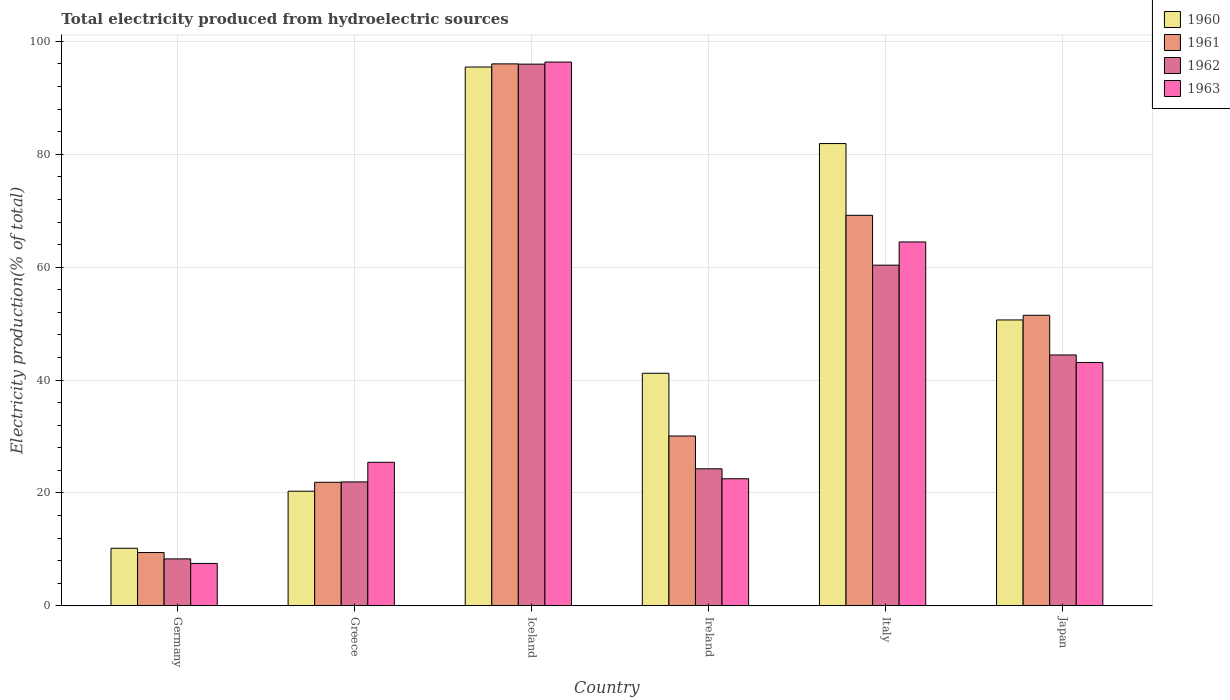How many different coloured bars are there?
Make the answer very short. 4. Are the number of bars per tick equal to the number of legend labels?
Provide a short and direct response. Yes. What is the label of the 1st group of bars from the left?
Your response must be concise. Germany. What is the total electricity produced in 1962 in Greece?
Your response must be concise. 21.95. Across all countries, what is the maximum total electricity produced in 1960?
Your response must be concise. 95.46. Across all countries, what is the minimum total electricity produced in 1961?
Give a very brief answer. 9.44. What is the total total electricity produced in 1963 in the graph?
Provide a succinct answer. 259.36. What is the difference between the total electricity produced in 1963 in Greece and that in Japan?
Provide a succinct answer. -17.69. What is the difference between the total electricity produced in 1960 in Germany and the total electricity produced in 1963 in Japan?
Ensure brevity in your answer.  -32.92. What is the average total electricity produced in 1963 per country?
Your response must be concise. 43.23. What is the difference between the total electricity produced of/in 1960 and total electricity produced of/in 1961 in Germany?
Provide a succinct answer. 0.76. What is the ratio of the total electricity produced in 1963 in Iceland to that in Japan?
Offer a terse response. 2.23. Is the total electricity produced in 1960 in Germany less than that in Japan?
Your answer should be very brief. Yes. What is the difference between the highest and the second highest total electricity produced in 1961?
Your response must be concise. 44.54. What is the difference between the highest and the lowest total electricity produced in 1960?
Keep it short and to the point. 85.27. In how many countries, is the total electricity produced in 1960 greater than the average total electricity produced in 1960 taken over all countries?
Your answer should be very brief. 3. Is it the case that in every country, the sum of the total electricity produced in 1961 and total electricity produced in 1963 is greater than the sum of total electricity produced in 1962 and total electricity produced in 1960?
Make the answer very short. No. What does the 3rd bar from the left in Japan represents?
Offer a very short reply. 1962. Are all the bars in the graph horizontal?
Offer a very short reply. No. What is the difference between two consecutive major ticks on the Y-axis?
Your response must be concise. 20. Are the values on the major ticks of Y-axis written in scientific E-notation?
Offer a very short reply. No. Does the graph contain grids?
Ensure brevity in your answer.  Yes. How many legend labels are there?
Offer a very short reply. 4. What is the title of the graph?
Offer a very short reply. Total electricity produced from hydroelectric sources. What is the Electricity production(% of total) of 1960 in Germany?
Offer a very short reply. 10.19. What is the Electricity production(% of total) of 1961 in Germany?
Your response must be concise. 9.44. What is the Electricity production(% of total) in 1962 in Germany?
Make the answer very short. 8.31. What is the Electricity production(% of total) in 1963 in Germany?
Give a very brief answer. 7.5. What is the Electricity production(% of total) in 1960 in Greece?
Offer a very short reply. 20.31. What is the Electricity production(% of total) of 1961 in Greece?
Offer a terse response. 21.88. What is the Electricity production(% of total) of 1962 in Greece?
Your response must be concise. 21.95. What is the Electricity production(% of total) of 1963 in Greece?
Your response must be concise. 25.43. What is the Electricity production(% of total) in 1960 in Iceland?
Make the answer very short. 95.46. What is the Electricity production(% of total) of 1961 in Iceland?
Provide a succinct answer. 96.02. What is the Electricity production(% of total) of 1962 in Iceland?
Offer a very short reply. 95.97. What is the Electricity production(% of total) of 1963 in Iceland?
Your response must be concise. 96.34. What is the Electricity production(% of total) in 1960 in Ireland?
Provide a short and direct response. 41.2. What is the Electricity production(% of total) of 1961 in Ireland?
Ensure brevity in your answer.  30.09. What is the Electricity production(% of total) in 1962 in Ireland?
Provide a short and direct response. 24.27. What is the Electricity production(% of total) in 1963 in Ireland?
Your response must be concise. 22.51. What is the Electricity production(% of total) in 1960 in Italy?
Offer a terse response. 81.9. What is the Electricity production(% of total) in 1961 in Italy?
Your answer should be compact. 69.19. What is the Electricity production(% of total) of 1962 in Italy?
Your answer should be compact. 60.35. What is the Electricity production(% of total) of 1963 in Italy?
Keep it short and to the point. 64.47. What is the Electricity production(% of total) in 1960 in Japan?
Give a very brief answer. 50.65. What is the Electricity production(% of total) in 1961 in Japan?
Your answer should be very brief. 51.48. What is the Electricity production(% of total) of 1962 in Japan?
Provide a short and direct response. 44.44. What is the Electricity production(% of total) of 1963 in Japan?
Provide a short and direct response. 43.11. Across all countries, what is the maximum Electricity production(% of total) of 1960?
Your response must be concise. 95.46. Across all countries, what is the maximum Electricity production(% of total) of 1961?
Provide a succinct answer. 96.02. Across all countries, what is the maximum Electricity production(% of total) in 1962?
Offer a terse response. 95.97. Across all countries, what is the maximum Electricity production(% of total) of 1963?
Offer a very short reply. 96.34. Across all countries, what is the minimum Electricity production(% of total) of 1960?
Make the answer very short. 10.19. Across all countries, what is the minimum Electricity production(% of total) in 1961?
Provide a short and direct response. 9.44. Across all countries, what is the minimum Electricity production(% of total) of 1962?
Keep it short and to the point. 8.31. Across all countries, what is the minimum Electricity production(% of total) of 1963?
Provide a short and direct response. 7.5. What is the total Electricity production(% of total) of 1960 in the graph?
Make the answer very short. 299.71. What is the total Electricity production(% of total) in 1961 in the graph?
Offer a terse response. 278.09. What is the total Electricity production(% of total) of 1962 in the graph?
Your response must be concise. 255.3. What is the total Electricity production(% of total) in 1963 in the graph?
Your answer should be very brief. 259.36. What is the difference between the Electricity production(% of total) in 1960 in Germany and that in Greece?
Your answer should be compact. -10.11. What is the difference between the Electricity production(% of total) in 1961 in Germany and that in Greece?
Your answer should be compact. -12.45. What is the difference between the Electricity production(% of total) of 1962 in Germany and that in Greece?
Ensure brevity in your answer.  -13.64. What is the difference between the Electricity production(% of total) of 1963 in Germany and that in Greece?
Provide a short and direct response. -17.93. What is the difference between the Electricity production(% of total) in 1960 in Germany and that in Iceland?
Your response must be concise. -85.27. What is the difference between the Electricity production(% of total) of 1961 in Germany and that in Iceland?
Give a very brief answer. -86.58. What is the difference between the Electricity production(% of total) of 1962 in Germany and that in Iceland?
Your answer should be very brief. -87.67. What is the difference between the Electricity production(% of total) in 1963 in Germany and that in Iceland?
Your answer should be compact. -88.84. What is the difference between the Electricity production(% of total) of 1960 in Germany and that in Ireland?
Provide a succinct answer. -31.01. What is the difference between the Electricity production(% of total) of 1961 in Germany and that in Ireland?
Provide a short and direct response. -20.65. What is the difference between the Electricity production(% of total) in 1962 in Germany and that in Ireland?
Your response must be concise. -15.96. What is the difference between the Electricity production(% of total) of 1963 in Germany and that in Ireland?
Your answer should be very brief. -15.01. What is the difference between the Electricity production(% of total) of 1960 in Germany and that in Italy?
Give a very brief answer. -71.71. What is the difference between the Electricity production(% of total) in 1961 in Germany and that in Italy?
Keep it short and to the point. -59.75. What is the difference between the Electricity production(% of total) in 1962 in Germany and that in Italy?
Keep it short and to the point. -52.05. What is the difference between the Electricity production(% of total) of 1963 in Germany and that in Italy?
Provide a succinct answer. -56.97. What is the difference between the Electricity production(% of total) in 1960 in Germany and that in Japan?
Ensure brevity in your answer.  -40.46. What is the difference between the Electricity production(% of total) in 1961 in Germany and that in Japan?
Make the answer very short. -42.04. What is the difference between the Electricity production(% of total) in 1962 in Germany and that in Japan?
Make the answer very short. -36.14. What is the difference between the Electricity production(% of total) of 1963 in Germany and that in Japan?
Provide a short and direct response. -35.61. What is the difference between the Electricity production(% of total) of 1960 in Greece and that in Iceland?
Keep it short and to the point. -75.16. What is the difference between the Electricity production(% of total) in 1961 in Greece and that in Iceland?
Your answer should be compact. -74.14. What is the difference between the Electricity production(% of total) in 1962 in Greece and that in Iceland?
Your answer should be very brief. -74.02. What is the difference between the Electricity production(% of total) in 1963 in Greece and that in Iceland?
Offer a terse response. -70.91. What is the difference between the Electricity production(% of total) of 1960 in Greece and that in Ireland?
Ensure brevity in your answer.  -20.9. What is the difference between the Electricity production(% of total) of 1961 in Greece and that in Ireland?
Offer a very short reply. -8.2. What is the difference between the Electricity production(% of total) of 1962 in Greece and that in Ireland?
Ensure brevity in your answer.  -2.32. What is the difference between the Electricity production(% of total) in 1963 in Greece and that in Ireland?
Provide a short and direct response. 2.92. What is the difference between the Electricity production(% of total) of 1960 in Greece and that in Italy?
Give a very brief answer. -61.59. What is the difference between the Electricity production(% of total) in 1961 in Greece and that in Italy?
Your answer should be compact. -47.31. What is the difference between the Electricity production(% of total) in 1962 in Greece and that in Italy?
Make the answer very short. -38.4. What is the difference between the Electricity production(% of total) of 1963 in Greece and that in Italy?
Make the answer very short. -39.04. What is the difference between the Electricity production(% of total) in 1960 in Greece and that in Japan?
Make the answer very short. -30.34. What is the difference between the Electricity production(% of total) of 1961 in Greece and that in Japan?
Offer a terse response. -29.59. What is the difference between the Electricity production(% of total) of 1962 in Greece and that in Japan?
Ensure brevity in your answer.  -22.49. What is the difference between the Electricity production(% of total) of 1963 in Greece and that in Japan?
Make the answer very short. -17.69. What is the difference between the Electricity production(% of total) of 1960 in Iceland and that in Ireland?
Provide a succinct answer. 54.26. What is the difference between the Electricity production(% of total) in 1961 in Iceland and that in Ireland?
Offer a very short reply. 65.93. What is the difference between the Electricity production(% of total) of 1962 in Iceland and that in Ireland?
Your answer should be compact. 71.7. What is the difference between the Electricity production(% of total) in 1963 in Iceland and that in Ireland?
Your answer should be compact. 73.83. What is the difference between the Electricity production(% of total) of 1960 in Iceland and that in Italy?
Provide a short and direct response. 13.56. What is the difference between the Electricity production(% of total) of 1961 in Iceland and that in Italy?
Provide a short and direct response. 26.83. What is the difference between the Electricity production(% of total) in 1962 in Iceland and that in Italy?
Give a very brief answer. 35.62. What is the difference between the Electricity production(% of total) in 1963 in Iceland and that in Italy?
Offer a very short reply. 31.87. What is the difference between the Electricity production(% of total) of 1960 in Iceland and that in Japan?
Your response must be concise. 44.81. What is the difference between the Electricity production(% of total) of 1961 in Iceland and that in Japan?
Offer a terse response. 44.54. What is the difference between the Electricity production(% of total) in 1962 in Iceland and that in Japan?
Offer a terse response. 51.53. What is the difference between the Electricity production(% of total) of 1963 in Iceland and that in Japan?
Keep it short and to the point. 53.23. What is the difference between the Electricity production(% of total) of 1960 in Ireland and that in Italy?
Keep it short and to the point. -40.7. What is the difference between the Electricity production(% of total) in 1961 in Ireland and that in Italy?
Provide a succinct answer. -39.1. What is the difference between the Electricity production(% of total) of 1962 in Ireland and that in Italy?
Your answer should be compact. -36.08. What is the difference between the Electricity production(% of total) of 1963 in Ireland and that in Italy?
Your response must be concise. -41.96. What is the difference between the Electricity production(% of total) in 1960 in Ireland and that in Japan?
Offer a terse response. -9.45. What is the difference between the Electricity production(% of total) of 1961 in Ireland and that in Japan?
Keep it short and to the point. -21.39. What is the difference between the Electricity production(% of total) in 1962 in Ireland and that in Japan?
Keep it short and to the point. -20.17. What is the difference between the Electricity production(% of total) of 1963 in Ireland and that in Japan?
Give a very brief answer. -20.61. What is the difference between the Electricity production(% of total) in 1960 in Italy and that in Japan?
Offer a very short reply. 31.25. What is the difference between the Electricity production(% of total) in 1961 in Italy and that in Japan?
Give a very brief answer. 17.71. What is the difference between the Electricity production(% of total) of 1962 in Italy and that in Japan?
Provide a succinct answer. 15.91. What is the difference between the Electricity production(% of total) in 1963 in Italy and that in Japan?
Keep it short and to the point. 21.35. What is the difference between the Electricity production(% of total) in 1960 in Germany and the Electricity production(% of total) in 1961 in Greece?
Give a very brief answer. -11.69. What is the difference between the Electricity production(% of total) in 1960 in Germany and the Electricity production(% of total) in 1962 in Greece?
Make the answer very short. -11.76. What is the difference between the Electricity production(% of total) in 1960 in Germany and the Electricity production(% of total) in 1963 in Greece?
Your answer should be very brief. -15.24. What is the difference between the Electricity production(% of total) in 1961 in Germany and the Electricity production(% of total) in 1962 in Greece?
Make the answer very short. -12.51. What is the difference between the Electricity production(% of total) in 1961 in Germany and the Electricity production(% of total) in 1963 in Greece?
Your answer should be compact. -15.99. What is the difference between the Electricity production(% of total) of 1962 in Germany and the Electricity production(% of total) of 1963 in Greece?
Your response must be concise. -17.12. What is the difference between the Electricity production(% of total) in 1960 in Germany and the Electricity production(% of total) in 1961 in Iceland?
Your response must be concise. -85.83. What is the difference between the Electricity production(% of total) in 1960 in Germany and the Electricity production(% of total) in 1962 in Iceland?
Offer a terse response. -85.78. What is the difference between the Electricity production(% of total) in 1960 in Germany and the Electricity production(% of total) in 1963 in Iceland?
Ensure brevity in your answer.  -86.15. What is the difference between the Electricity production(% of total) of 1961 in Germany and the Electricity production(% of total) of 1962 in Iceland?
Your answer should be compact. -86.54. What is the difference between the Electricity production(% of total) in 1961 in Germany and the Electricity production(% of total) in 1963 in Iceland?
Your answer should be very brief. -86.9. What is the difference between the Electricity production(% of total) in 1962 in Germany and the Electricity production(% of total) in 1963 in Iceland?
Provide a succinct answer. -88.03. What is the difference between the Electricity production(% of total) of 1960 in Germany and the Electricity production(% of total) of 1961 in Ireland?
Make the answer very short. -19.89. What is the difference between the Electricity production(% of total) of 1960 in Germany and the Electricity production(% of total) of 1962 in Ireland?
Offer a very short reply. -14.08. What is the difference between the Electricity production(% of total) of 1960 in Germany and the Electricity production(% of total) of 1963 in Ireland?
Keep it short and to the point. -12.32. What is the difference between the Electricity production(% of total) in 1961 in Germany and the Electricity production(% of total) in 1962 in Ireland?
Your response must be concise. -14.84. What is the difference between the Electricity production(% of total) of 1961 in Germany and the Electricity production(% of total) of 1963 in Ireland?
Your answer should be very brief. -13.07. What is the difference between the Electricity production(% of total) in 1962 in Germany and the Electricity production(% of total) in 1963 in Ireland?
Provide a succinct answer. -14.2. What is the difference between the Electricity production(% of total) of 1960 in Germany and the Electricity production(% of total) of 1961 in Italy?
Your answer should be compact. -59. What is the difference between the Electricity production(% of total) of 1960 in Germany and the Electricity production(% of total) of 1962 in Italy?
Your answer should be very brief. -50.16. What is the difference between the Electricity production(% of total) of 1960 in Germany and the Electricity production(% of total) of 1963 in Italy?
Make the answer very short. -54.28. What is the difference between the Electricity production(% of total) in 1961 in Germany and the Electricity production(% of total) in 1962 in Italy?
Keep it short and to the point. -50.92. What is the difference between the Electricity production(% of total) in 1961 in Germany and the Electricity production(% of total) in 1963 in Italy?
Make the answer very short. -55.03. What is the difference between the Electricity production(% of total) of 1962 in Germany and the Electricity production(% of total) of 1963 in Italy?
Your answer should be compact. -56.16. What is the difference between the Electricity production(% of total) of 1960 in Germany and the Electricity production(% of total) of 1961 in Japan?
Provide a succinct answer. -41.28. What is the difference between the Electricity production(% of total) of 1960 in Germany and the Electricity production(% of total) of 1962 in Japan?
Keep it short and to the point. -34.25. What is the difference between the Electricity production(% of total) of 1960 in Germany and the Electricity production(% of total) of 1963 in Japan?
Give a very brief answer. -32.92. What is the difference between the Electricity production(% of total) of 1961 in Germany and the Electricity production(% of total) of 1962 in Japan?
Your answer should be very brief. -35.01. What is the difference between the Electricity production(% of total) in 1961 in Germany and the Electricity production(% of total) in 1963 in Japan?
Provide a short and direct response. -33.68. What is the difference between the Electricity production(% of total) of 1962 in Germany and the Electricity production(% of total) of 1963 in Japan?
Provide a short and direct response. -34.81. What is the difference between the Electricity production(% of total) of 1960 in Greece and the Electricity production(% of total) of 1961 in Iceland?
Offer a terse response. -75.71. What is the difference between the Electricity production(% of total) of 1960 in Greece and the Electricity production(% of total) of 1962 in Iceland?
Give a very brief answer. -75.67. What is the difference between the Electricity production(% of total) of 1960 in Greece and the Electricity production(% of total) of 1963 in Iceland?
Give a very brief answer. -76.04. What is the difference between the Electricity production(% of total) of 1961 in Greece and the Electricity production(% of total) of 1962 in Iceland?
Ensure brevity in your answer.  -74.09. What is the difference between the Electricity production(% of total) in 1961 in Greece and the Electricity production(% of total) in 1963 in Iceland?
Keep it short and to the point. -74.46. What is the difference between the Electricity production(% of total) of 1962 in Greece and the Electricity production(% of total) of 1963 in Iceland?
Your response must be concise. -74.39. What is the difference between the Electricity production(% of total) of 1960 in Greece and the Electricity production(% of total) of 1961 in Ireland?
Your answer should be compact. -9.78. What is the difference between the Electricity production(% of total) in 1960 in Greece and the Electricity production(% of total) in 1962 in Ireland?
Keep it short and to the point. -3.97. What is the difference between the Electricity production(% of total) in 1960 in Greece and the Electricity production(% of total) in 1963 in Ireland?
Offer a very short reply. -2.2. What is the difference between the Electricity production(% of total) in 1961 in Greece and the Electricity production(% of total) in 1962 in Ireland?
Your answer should be very brief. -2.39. What is the difference between the Electricity production(% of total) in 1961 in Greece and the Electricity production(% of total) in 1963 in Ireland?
Ensure brevity in your answer.  -0.63. What is the difference between the Electricity production(% of total) of 1962 in Greece and the Electricity production(% of total) of 1963 in Ireland?
Provide a short and direct response. -0.56. What is the difference between the Electricity production(% of total) of 1960 in Greece and the Electricity production(% of total) of 1961 in Italy?
Keep it short and to the point. -48.88. What is the difference between the Electricity production(% of total) of 1960 in Greece and the Electricity production(% of total) of 1962 in Italy?
Your answer should be very brief. -40.05. What is the difference between the Electricity production(% of total) of 1960 in Greece and the Electricity production(% of total) of 1963 in Italy?
Give a very brief answer. -44.16. What is the difference between the Electricity production(% of total) of 1961 in Greece and the Electricity production(% of total) of 1962 in Italy?
Provide a short and direct response. -38.47. What is the difference between the Electricity production(% of total) in 1961 in Greece and the Electricity production(% of total) in 1963 in Italy?
Give a very brief answer. -42.58. What is the difference between the Electricity production(% of total) of 1962 in Greece and the Electricity production(% of total) of 1963 in Italy?
Your answer should be very brief. -42.52. What is the difference between the Electricity production(% of total) of 1960 in Greece and the Electricity production(% of total) of 1961 in Japan?
Give a very brief answer. -31.17. What is the difference between the Electricity production(% of total) of 1960 in Greece and the Electricity production(% of total) of 1962 in Japan?
Your answer should be very brief. -24.14. What is the difference between the Electricity production(% of total) of 1960 in Greece and the Electricity production(% of total) of 1963 in Japan?
Offer a very short reply. -22.81. What is the difference between the Electricity production(% of total) of 1961 in Greece and the Electricity production(% of total) of 1962 in Japan?
Offer a very short reply. -22.56. What is the difference between the Electricity production(% of total) in 1961 in Greece and the Electricity production(% of total) in 1963 in Japan?
Ensure brevity in your answer.  -21.23. What is the difference between the Electricity production(% of total) of 1962 in Greece and the Electricity production(% of total) of 1963 in Japan?
Your response must be concise. -21.16. What is the difference between the Electricity production(% of total) in 1960 in Iceland and the Electricity production(% of total) in 1961 in Ireland?
Keep it short and to the point. 65.38. What is the difference between the Electricity production(% of total) of 1960 in Iceland and the Electricity production(% of total) of 1962 in Ireland?
Keep it short and to the point. 71.19. What is the difference between the Electricity production(% of total) of 1960 in Iceland and the Electricity production(% of total) of 1963 in Ireland?
Offer a very short reply. 72.95. What is the difference between the Electricity production(% of total) of 1961 in Iceland and the Electricity production(% of total) of 1962 in Ireland?
Make the answer very short. 71.75. What is the difference between the Electricity production(% of total) in 1961 in Iceland and the Electricity production(% of total) in 1963 in Ireland?
Ensure brevity in your answer.  73.51. What is the difference between the Electricity production(% of total) of 1962 in Iceland and the Electricity production(% of total) of 1963 in Ireland?
Your response must be concise. 73.47. What is the difference between the Electricity production(% of total) of 1960 in Iceland and the Electricity production(% of total) of 1961 in Italy?
Provide a succinct answer. 26.27. What is the difference between the Electricity production(% of total) of 1960 in Iceland and the Electricity production(% of total) of 1962 in Italy?
Keep it short and to the point. 35.11. What is the difference between the Electricity production(% of total) of 1960 in Iceland and the Electricity production(% of total) of 1963 in Italy?
Your answer should be compact. 30.99. What is the difference between the Electricity production(% of total) in 1961 in Iceland and the Electricity production(% of total) in 1962 in Italy?
Your answer should be compact. 35.67. What is the difference between the Electricity production(% of total) of 1961 in Iceland and the Electricity production(% of total) of 1963 in Italy?
Your response must be concise. 31.55. What is the difference between the Electricity production(% of total) of 1962 in Iceland and the Electricity production(% of total) of 1963 in Italy?
Make the answer very short. 31.51. What is the difference between the Electricity production(% of total) of 1960 in Iceland and the Electricity production(% of total) of 1961 in Japan?
Provide a succinct answer. 43.99. What is the difference between the Electricity production(% of total) of 1960 in Iceland and the Electricity production(% of total) of 1962 in Japan?
Provide a short and direct response. 51.02. What is the difference between the Electricity production(% of total) in 1960 in Iceland and the Electricity production(% of total) in 1963 in Japan?
Offer a terse response. 52.35. What is the difference between the Electricity production(% of total) of 1961 in Iceland and the Electricity production(% of total) of 1962 in Japan?
Provide a succinct answer. 51.58. What is the difference between the Electricity production(% of total) of 1961 in Iceland and the Electricity production(% of total) of 1963 in Japan?
Keep it short and to the point. 52.91. What is the difference between the Electricity production(% of total) in 1962 in Iceland and the Electricity production(% of total) in 1963 in Japan?
Offer a terse response. 52.86. What is the difference between the Electricity production(% of total) in 1960 in Ireland and the Electricity production(% of total) in 1961 in Italy?
Keep it short and to the point. -27.99. What is the difference between the Electricity production(% of total) of 1960 in Ireland and the Electricity production(% of total) of 1962 in Italy?
Your answer should be compact. -19.15. What is the difference between the Electricity production(% of total) of 1960 in Ireland and the Electricity production(% of total) of 1963 in Italy?
Give a very brief answer. -23.27. What is the difference between the Electricity production(% of total) in 1961 in Ireland and the Electricity production(% of total) in 1962 in Italy?
Provide a succinct answer. -30.27. What is the difference between the Electricity production(% of total) of 1961 in Ireland and the Electricity production(% of total) of 1963 in Italy?
Keep it short and to the point. -34.38. What is the difference between the Electricity production(% of total) in 1962 in Ireland and the Electricity production(% of total) in 1963 in Italy?
Ensure brevity in your answer.  -40.2. What is the difference between the Electricity production(% of total) in 1960 in Ireland and the Electricity production(% of total) in 1961 in Japan?
Your response must be concise. -10.27. What is the difference between the Electricity production(% of total) in 1960 in Ireland and the Electricity production(% of total) in 1962 in Japan?
Your response must be concise. -3.24. What is the difference between the Electricity production(% of total) of 1960 in Ireland and the Electricity production(% of total) of 1963 in Japan?
Your response must be concise. -1.91. What is the difference between the Electricity production(% of total) in 1961 in Ireland and the Electricity production(% of total) in 1962 in Japan?
Provide a short and direct response. -14.36. What is the difference between the Electricity production(% of total) of 1961 in Ireland and the Electricity production(% of total) of 1963 in Japan?
Provide a short and direct response. -13.03. What is the difference between the Electricity production(% of total) in 1962 in Ireland and the Electricity production(% of total) in 1963 in Japan?
Your answer should be compact. -18.84. What is the difference between the Electricity production(% of total) of 1960 in Italy and the Electricity production(% of total) of 1961 in Japan?
Offer a very short reply. 30.42. What is the difference between the Electricity production(% of total) of 1960 in Italy and the Electricity production(% of total) of 1962 in Japan?
Offer a terse response. 37.46. What is the difference between the Electricity production(% of total) of 1960 in Italy and the Electricity production(% of total) of 1963 in Japan?
Give a very brief answer. 38.79. What is the difference between the Electricity production(% of total) of 1961 in Italy and the Electricity production(% of total) of 1962 in Japan?
Ensure brevity in your answer.  24.75. What is the difference between the Electricity production(% of total) of 1961 in Italy and the Electricity production(% of total) of 1963 in Japan?
Provide a short and direct response. 26.08. What is the difference between the Electricity production(% of total) of 1962 in Italy and the Electricity production(% of total) of 1963 in Japan?
Your answer should be compact. 17.24. What is the average Electricity production(% of total) of 1960 per country?
Provide a short and direct response. 49.95. What is the average Electricity production(% of total) of 1961 per country?
Your answer should be compact. 46.35. What is the average Electricity production(% of total) of 1962 per country?
Your answer should be compact. 42.55. What is the average Electricity production(% of total) of 1963 per country?
Provide a short and direct response. 43.23. What is the difference between the Electricity production(% of total) of 1960 and Electricity production(% of total) of 1961 in Germany?
Offer a very short reply. 0.76. What is the difference between the Electricity production(% of total) of 1960 and Electricity production(% of total) of 1962 in Germany?
Keep it short and to the point. 1.88. What is the difference between the Electricity production(% of total) of 1960 and Electricity production(% of total) of 1963 in Germany?
Give a very brief answer. 2.69. What is the difference between the Electricity production(% of total) of 1961 and Electricity production(% of total) of 1962 in Germany?
Offer a terse response. 1.13. What is the difference between the Electricity production(% of total) of 1961 and Electricity production(% of total) of 1963 in Germany?
Your response must be concise. 1.94. What is the difference between the Electricity production(% of total) in 1962 and Electricity production(% of total) in 1963 in Germany?
Your answer should be very brief. 0.81. What is the difference between the Electricity production(% of total) of 1960 and Electricity production(% of total) of 1961 in Greece?
Offer a terse response. -1.58. What is the difference between the Electricity production(% of total) of 1960 and Electricity production(% of total) of 1962 in Greece?
Ensure brevity in your answer.  -1.64. What is the difference between the Electricity production(% of total) of 1960 and Electricity production(% of total) of 1963 in Greece?
Your response must be concise. -5.12. What is the difference between the Electricity production(% of total) in 1961 and Electricity production(% of total) in 1962 in Greece?
Give a very brief answer. -0.07. What is the difference between the Electricity production(% of total) in 1961 and Electricity production(% of total) in 1963 in Greece?
Your response must be concise. -3.54. What is the difference between the Electricity production(% of total) in 1962 and Electricity production(% of total) in 1963 in Greece?
Your answer should be very brief. -3.48. What is the difference between the Electricity production(% of total) in 1960 and Electricity production(% of total) in 1961 in Iceland?
Provide a short and direct response. -0.56. What is the difference between the Electricity production(% of total) in 1960 and Electricity production(% of total) in 1962 in Iceland?
Your answer should be very brief. -0.51. What is the difference between the Electricity production(% of total) in 1960 and Electricity production(% of total) in 1963 in Iceland?
Make the answer very short. -0.88. What is the difference between the Electricity production(% of total) in 1961 and Electricity production(% of total) in 1962 in Iceland?
Offer a terse response. 0.05. What is the difference between the Electricity production(% of total) of 1961 and Electricity production(% of total) of 1963 in Iceland?
Provide a succinct answer. -0.32. What is the difference between the Electricity production(% of total) in 1962 and Electricity production(% of total) in 1963 in Iceland?
Offer a very short reply. -0.37. What is the difference between the Electricity production(% of total) of 1960 and Electricity production(% of total) of 1961 in Ireland?
Your answer should be very brief. 11.12. What is the difference between the Electricity production(% of total) of 1960 and Electricity production(% of total) of 1962 in Ireland?
Keep it short and to the point. 16.93. What is the difference between the Electricity production(% of total) of 1960 and Electricity production(% of total) of 1963 in Ireland?
Keep it short and to the point. 18.69. What is the difference between the Electricity production(% of total) of 1961 and Electricity production(% of total) of 1962 in Ireland?
Make the answer very short. 5.81. What is the difference between the Electricity production(% of total) of 1961 and Electricity production(% of total) of 1963 in Ireland?
Provide a short and direct response. 7.58. What is the difference between the Electricity production(% of total) of 1962 and Electricity production(% of total) of 1963 in Ireland?
Offer a terse response. 1.76. What is the difference between the Electricity production(% of total) in 1960 and Electricity production(% of total) in 1961 in Italy?
Offer a terse response. 12.71. What is the difference between the Electricity production(% of total) in 1960 and Electricity production(% of total) in 1962 in Italy?
Provide a succinct answer. 21.55. What is the difference between the Electricity production(% of total) of 1960 and Electricity production(% of total) of 1963 in Italy?
Your response must be concise. 17.43. What is the difference between the Electricity production(% of total) of 1961 and Electricity production(% of total) of 1962 in Italy?
Offer a terse response. 8.84. What is the difference between the Electricity production(% of total) in 1961 and Electricity production(% of total) in 1963 in Italy?
Keep it short and to the point. 4.72. What is the difference between the Electricity production(% of total) in 1962 and Electricity production(% of total) in 1963 in Italy?
Give a very brief answer. -4.11. What is the difference between the Electricity production(% of total) in 1960 and Electricity production(% of total) in 1961 in Japan?
Your response must be concise. -0.83. What is the difference between the Electricity production(% of total) in 1960 and Electricity production(% of total) in 1962 in Japan?
Provide a succinct answer. 6.2. What is the difference between the Electricity production(% of total) of 1960 and Electricity production(% of total) of 1963 in Japan?
Make the answer very short. 7.54. What is the difference between the Electricity production(% of total) of 1961 and Electricity production(% of total) of 1962 in Japan?
Keep it short and to the point. 7.03. What is the difference between the Electricity production(% of total) of 1961 and Electricity production(% of total) of 1963 in Japan?
Keep it short and to the point. 8.36. What is the difference between the Electricity production(% of total) in 1962 and Electricity production(% of total) in 1963 in Japan?
Your response must be concise. 1.33. What is the ratio of the Electricity production(% of total) of 1960 in Germany to that in Greece?
Your answer should be compact. 0.5. What is the ratio of the Electricity production(% of total) of 1961 in Germany to that in Greece?
Your response must be concise. 0.43. What is the ratio of the Electricity production(% of total) in 1962 in Germany to that in Greece?
Offer a terse response. 0.38. What is the ratio of the Electricity production(% of total) in 1963 in Germany to that in Greece?
Provide a succinct answer. 0.29. What is the ratio of the Electricity production(% of total) of 1960 in Germany to that in Iceland?
Your response must be concise. 0.11. What is the ratio of the Electricity production(% of total) of 1961 in Germany to that in Iceland?
Give a very brief answer. 0.1. What is the ratio of the Electricity production(% of total) in 1962 in Germany to that in Iceland?
Your response must be concise. 0.09. What is the ratio of the Electricity production(% of total) in 1963 in Germany to that in Iceland?
Offer a very short reply. 0.08. What is the ratio of the Electricity production(% of total) in 1960 in Germany to that in Ireland?
Your answer should be compact. 0.25. What is the ratio of the Electricity production(% of total) in 1961 in Germany to that in Ireland?
Keep it short and to the point. 0.31. What is the ratio of the Electricity production(% of total) in 1962 in Germany to that in Ireland?
Make the answer very short. 0.34. What is the ratio of the Electricity production(% of total) in 1963 in Germany to that in Ireland?
Give a very brief answer. 0.33. What is the ratio of the Electricity production(% of total) in 1960 in Germany to that in Italy?
Offer a very short reply. 0.12. What is the ratio of the Electricity production(% of total) in 1961 in Germany to that in Italy?
Your response must be concise. 0.14. What is the ratio of the Electricity production(% of total) of 1962 in Germany to that in Italy?
Keep it short and to the point. 0.14. What is the ratio of the Electricity production(% of total) of 1963 in Germany to that in Italy?
Your response must be concise. 0.12. What is the ratio of the Electricity production(% of total) in 1960 in Germany to that in Japan?
Make the answer very short. 0.2. What is the ratio of the Electricity production(% of total) in 1961 in Germany to that in Japan?
Your response must be concise. 0.18. What is the ratio of the Electricity production(% of total) in 1962 in Germany to that in Japan?
Your answer should be very brief. 0.19. What is the ratio of the Electricity production(% of total) of 1963 in Germany to that in Japan?
Your response must be concise. 0.17. What is the ratio of the Electricity production(% of total) in 1960 in Greece to that in Iceland?
Keep it short and to the point. 0.21. What is the ratio of the Electricity production(% of total) of 1961 in Greece to that in Iceland?
Your answer should be compact. 0.23. What is the ratio of the Electricity production(% of total) in 1962 in Greece to that in Iceland?
Make the answer very short. 0.23. What is the ratio of the Electricity production(% of total) in 1963 in Greece to that in Iceland?
Offer a very short reply. 0.26. What is the ratio of the Electricity production(% of total) in 1960 in Greece to that in Ireland?
Ensure brevity in your answer.  0.49. What is the ratio of the Electricity production(% of total) in 1961 in Greece to that in Ireland?
Offer a very short reply. 0.73. What is the ratio of the Electricity production(% of total) of 1962 in Greece to that in Ireland?
Provide a succinct answer. 0.9. What is the ratio of the Electricity production(% of total) in 1963 in Greece to that in Ireland?
Keep it short and to the point. 1.13. What is the ratio of the Electricity production(% of total) in 1960 in Greece to that in Italy?
Keep it short and to the point. 0.25. What is the ratio of the Electricity production(% of total) of 1961 in Greece to that in Italy?
Provide a succinct answer. 0.32. What is the ratio of the Electricity production(% of total) of 1962 in Greece to that in Italy?
Your answer should be compact. 0.36. What is the ratio of the Electricity production(% of total) of 1963 in Greece to that in Italy?
Ensure brevity in your answer.  0.39. What is the ratio of the Electricity production(% of total) of 1960 in Greece to that in Japan?
Offer a very short reply. 0.4. What is the ratio of the Electricity production(% of total) of 1961 in Greece to that in Japan?
Ensure brevity in your answer.  0.43. What is the ratio of the Electricity production(% of total) of 1962 in Greece to that in Japan?
Ensure brevity in your answer.  0.49. What is the ratio of the Electricity production(% of total) of 1963 in Greece to that in Japan?
Your response must be concise. 0.59. What is the ratio of the Electricity production(% of total) of 1960 in Iceland to that in Ireland?
Keep it short and to the point. 2.32. What is the ratio of the Electricity production(% of total) of 1961 in Iceland to that in Ireland?
Ensure brevity in your answer.  3.19. What is the ratio of the Electricity production(% of total) of 1962 in Iceland to that in Ireland?
Provide a succinct answer. 3.95. What is the ratio of the Electricity production(% of total) in 1963 in Iceland to that in Ireland?
Provide a short and direct response. 4.28. What is the ratio of the Electricity production(% of total) in 1960 in Iceland to that in Italy?
Your answer should be very brief. 1.17. What is the ratio of the Electricity production(% of total) of 1961 in Iceland to that in Italy?
Your response must be concise. 1.39. What is the ratio of the Electricity production(% of total) in 1962 in Iceland to that in Italy?
Offer a terse response. 1.59. What is the ratio of the Electricity production(% of total) in 1963 in Iceland to that in Italy?
Your answer should be very brief. 1.49. What is the ratio of the Electricity production(% of total) of 1960 in Iceland to that in Japan?
Give a very brief answer. 1.88. What is the ratio of the Electricity production(% of total) of 1961 in Iceland to that in Japan?
Give a very brief answer. 1.87. What is the ratio of the Electricity production(% of total) of 1962 in Iceland to that in Japan?
Provide a succinct answer. 2.16. What is the ratio of the Electricity production(% of total) in 1963 in Iceland to that in Japan?
Offer a terse response. 2.23. What is the ratio of the Electricity production(% of total) of 1960 in Ireland to that in Italy?
Give a very brief answer. 0.5. What is the ratio of the Electricity production(% of total) in 1961 in Ireland to that in Italy?
Your answer should be very brief. 0.43. What is the ratio of the Electricity production(% of total) of 1962 in Ireland to that in Italy?
Your response must be concise. 0.4. What is the ratio of the Electricity production(% of total) of 1963 in Ireland to that in Italy?
Offer a very short reply. 0.35. What is the ratio of the Electricity production(% of total) of 1960 in Ireland to that in Japan?
Provide a short and direct response. 0.81. What is the ratio of the Electricity production(% of total) in 1961 in Ireland to that in Japan?
Ensure brevity in your answer.  0.58. What is the ratio of the Electricity production(% of total) in 1962 in Ireland to that in Japan?
Offer a very short reply. 0.55. What is the ratio of the Electricity production(% of total) of 1963 in Ireland to that in Japan?
Your response must be concise. 0.52. What is the ratio of the Electricity production(% of total) of 1960 in Italy to that in Japan?
Keep it short and to the point. 1.62. What is the ratio of the Electricity production(% of total) in 1961 in Italy to that in Japan?
Ensure brevity in your answer.  1.34. What is the ratio of the Electricity production(% of total) of 1962 in Italy to that in Japan?
Offer a very short reply. 1.36. What is the ratio of the Electricity production(% of total) of 1963 in Italy to that in Japan?
Make the answer very short. 1.5. What is the difference between the highest and the second highest Electricity production(% of total) in 1960?
Offer a terse response. 13.56. What is the difference between the highest and the second highest Electricity production(% of total) in 1961?
Keep it short and to the point. 26.83. What is the difference between the highest and the second highest Electricity production(% of total) in 1962?
Keep it short and to the point. 35.62. What is the difference between the highest and the second highest Electricity production(% of total) of 1963?
Offer a terse response. 31.87. What is the difference between the highest and the lowest Electricity production(% of total) of 1960?
Offer a terse response. 85.27. What is the difference between the highest and the lowest Electricity production(% of total) in 1961?
Provide a succinct answer. 86.58. What is the difference between the highest and the lowest Electricity production(% of total) of 1962?
Offer a very short reply. 87.67. What is the difference between the highest and the lowest Electricity production(% of total) of 1963?
Your response must be concise. 88.84. 